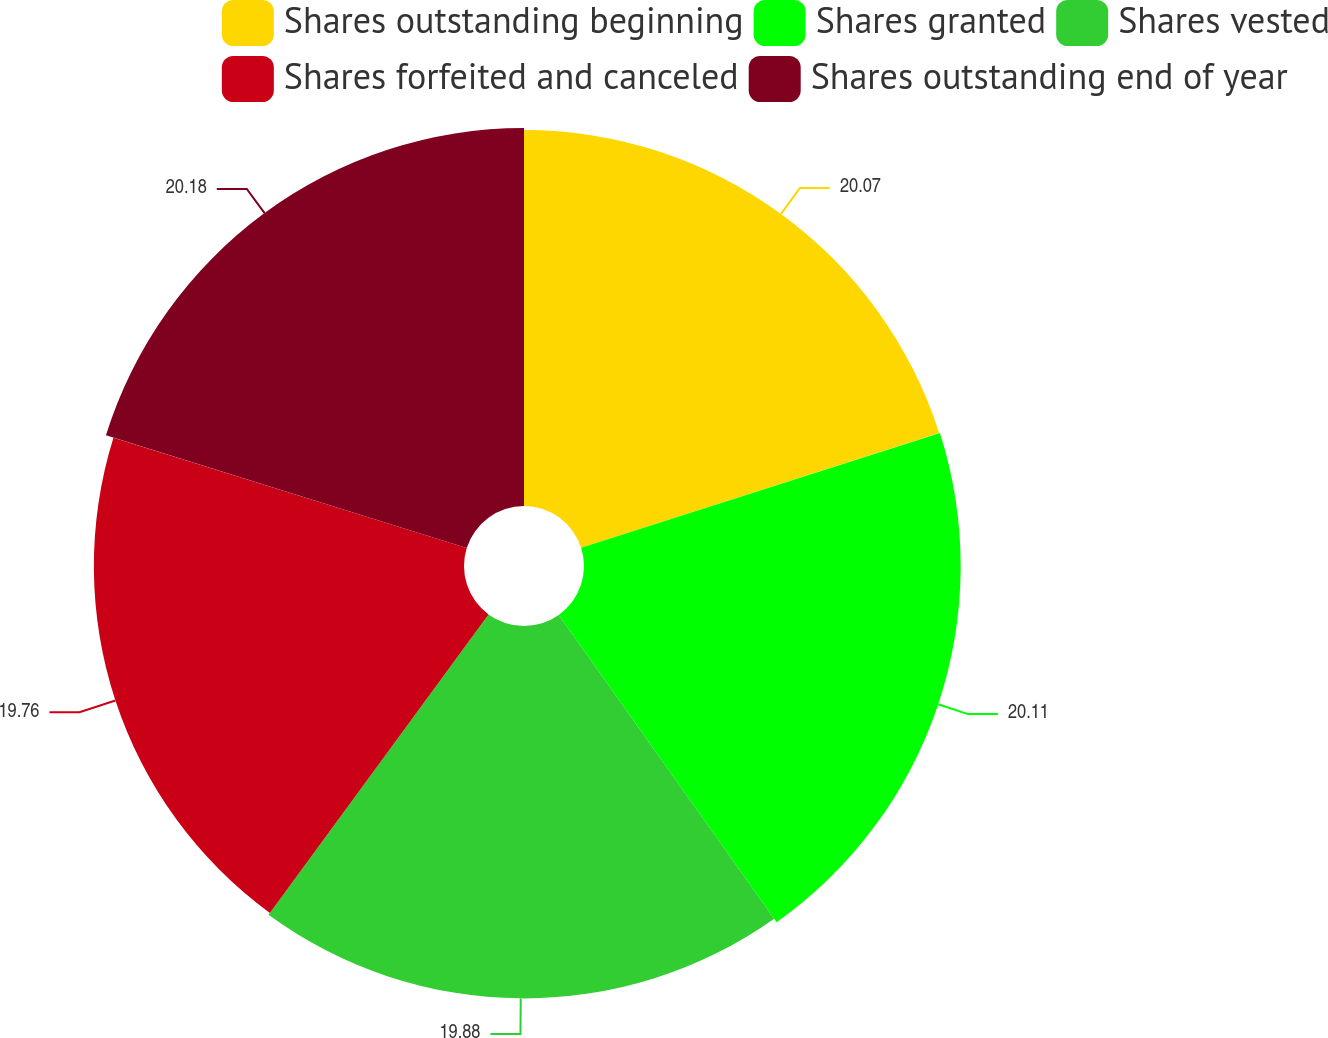<chart> <loc_0><loc_0><loc_500><loc_500><pie_chart><fcel>Shares outstanding beginning<fcel>Shares granted<fcel>Shares vested<fcel>Shares forfeited and canceled<fcel>Shares outstanding end of year<nl><fcel>20.07%<fcel>20.11%<fcel>19.88%<fcel>19.76%<fcel>20.18%<nl></chart> 